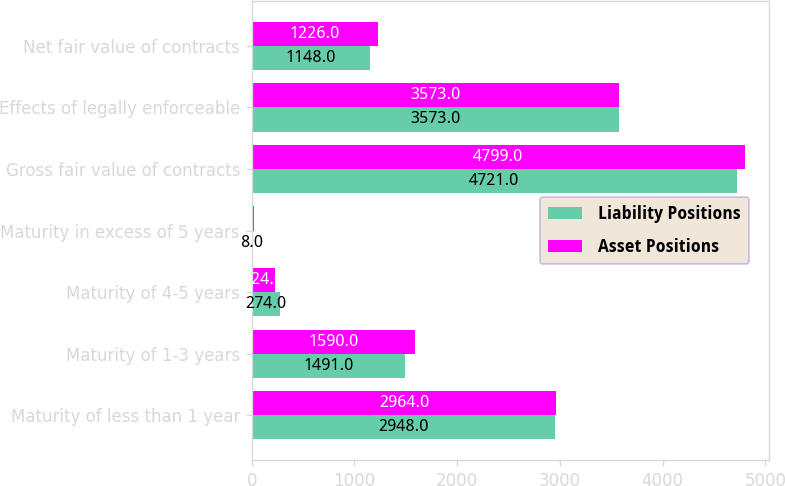<chart> <loc_0><loc_0><loc_500><loc_500><stacked_bar_chart><ecel><fcel>Maturity of less than 1 year<fcel>Maturity of 1-3 years<fcel>Maturity of 4-5 years<fcel>Maturity in excess of 5 years<fcel>Gross fair value of contracts<fcel>Effects of legally enforceable<fcel>Net fair value of contracts<nl><fcel>Liability Positions<fcel>2948<fcel>1491<fcel>274<fcel>8<fcel>4721<fcel>3573<fcel>1148<nl><fcel>Asset Positions<fcel>2964<fcel>1590<fcel>224<fcel>21<fcel>4799<fcel>3573<fcel>1226<nl></chart> 